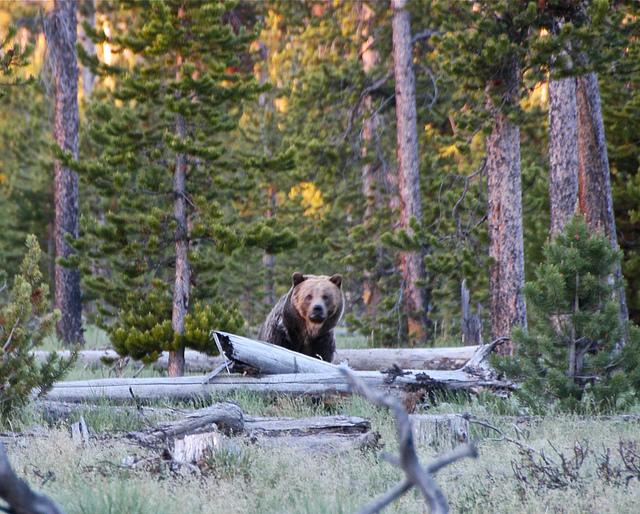What color is this bear?
Short answer required. Brown. What type of bear is in view?
Keep it brief. Grizzly. Are there any dead trees in the scene?
Answer briefly. Yes. Is this a good place to cook some food on a camp out?
Concise answer only. No. Is the bear angry?
Keep it brief. No. How many bears are here?
Keep it brief. 1. 